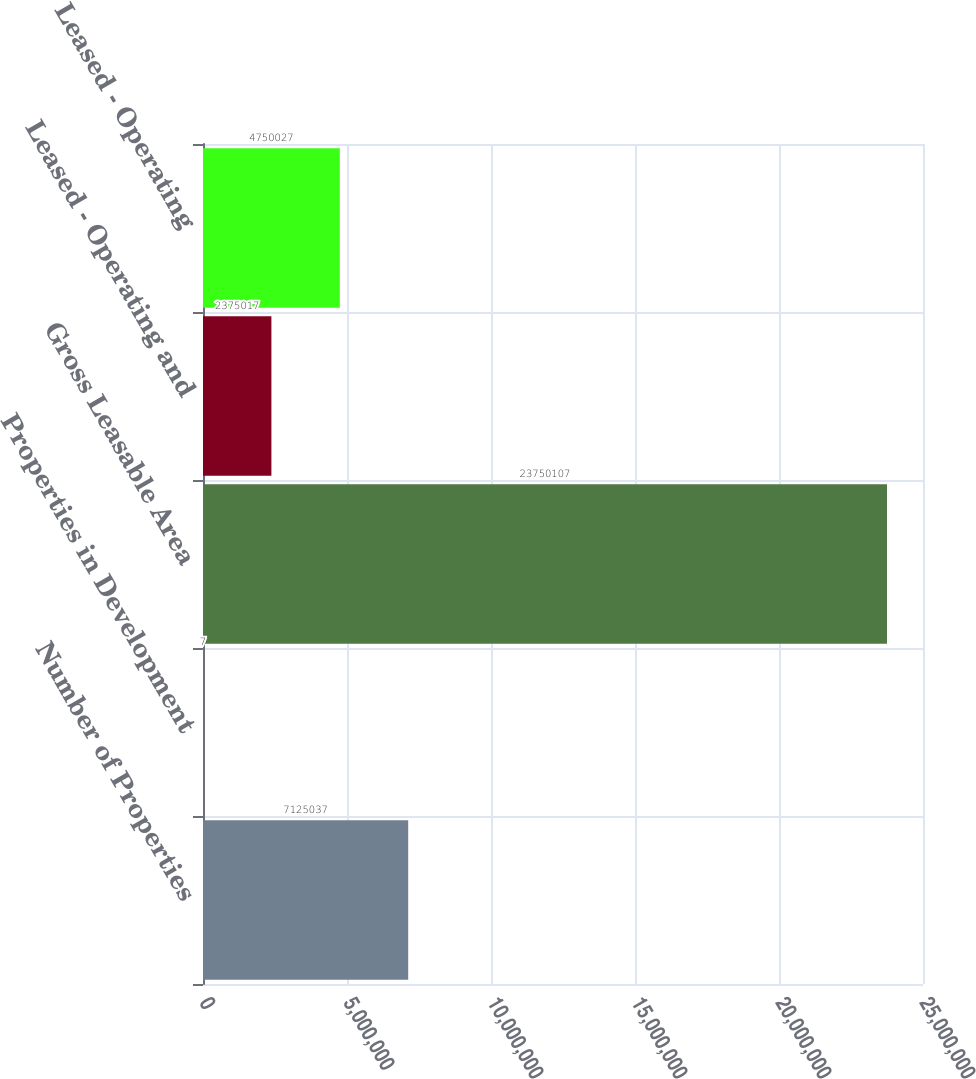Convert chart. <chart><loc_0><loc_0><loc_500><loc_500><bar_chart><fcel>Number of Properties<fcel>Properties in Development<fcel>Gross Leasable Area<fcel>Leased - Operating and<fcel>Leased - Operating<nl><fcel>7.12504e+06<fcel>7<fcel>2.37501e+07<fcel>2.37502e+06<fcel>4.75003e+06<nl></chart> 